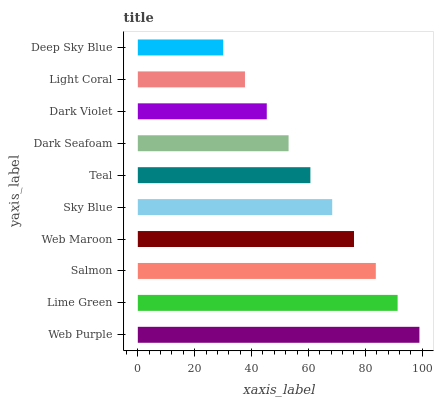Is Deep Sky Blue the minimum?
Answer yes or no. Yes. Is Web Purple the maximum?
Answer yes or no. Yes. Is Lime Green the minimum?
Answer yes or no. No. Is Lime Green the maximum?
Answer yes or no. No. Is Web Purple greater than Lime Green?
Answer yes or no. Yes. Is Lime Green less than Web Purple?
Answer yes or no. Yes. Is Lime Green greater than Web Purple?
Answer yes or no. No. Is Web Purple less than Lime Green?
Answer yes or no. No. Is Sky Blue the high median?
Answer yes or no. Yes. Is Teal the low median?
Answer yes or no. Yes. Is Dark Violet the high median?
Answer yes or no. No. Is Sky Blue the low median?
Answer yes or no. No. 